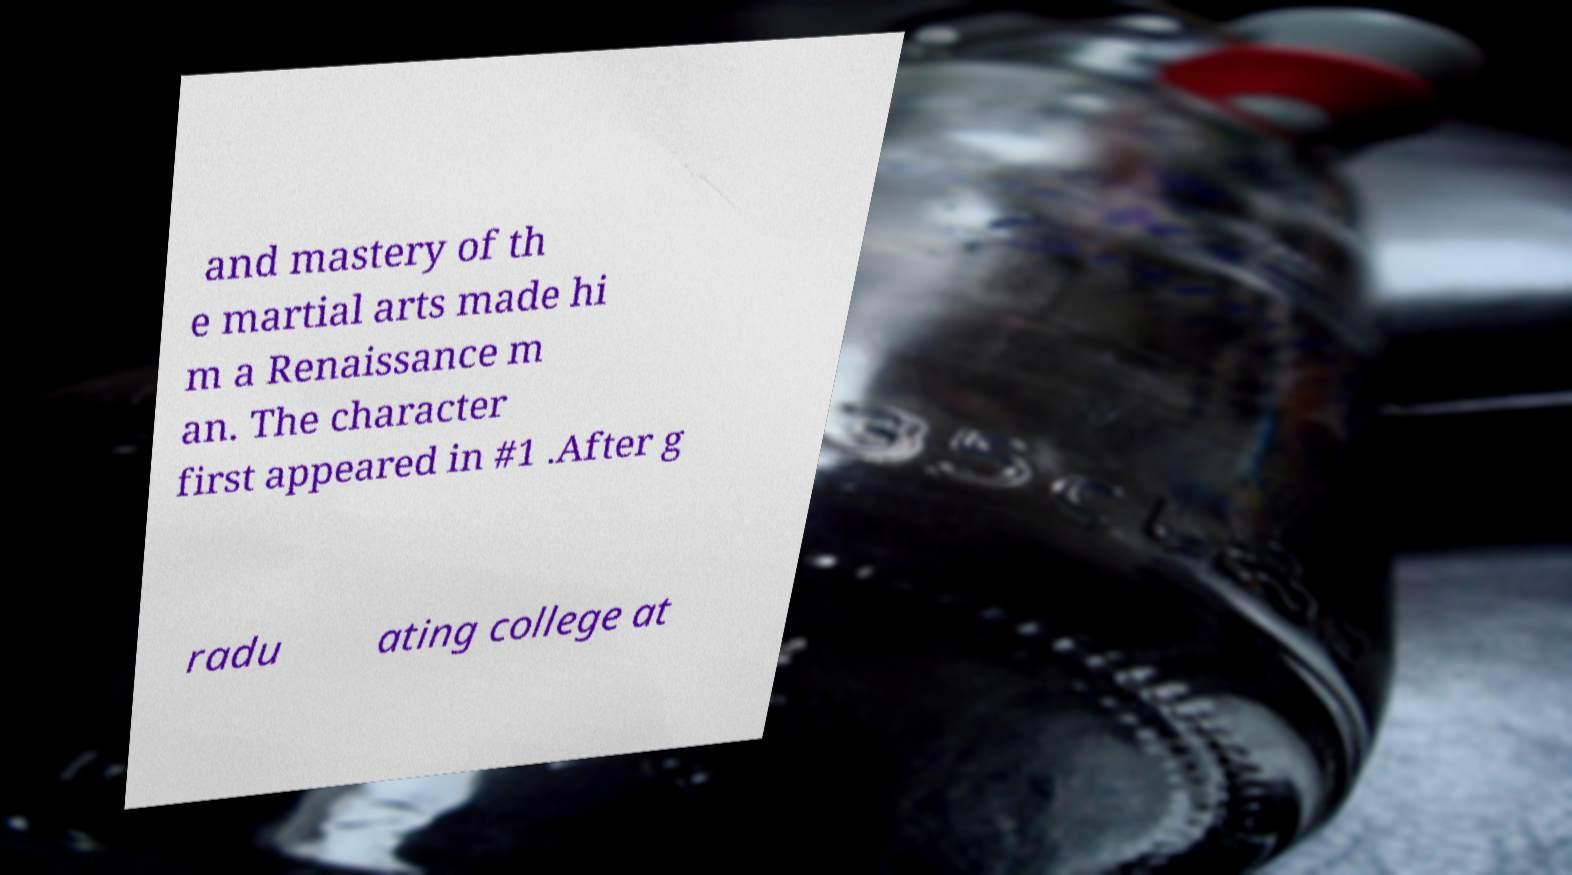Can you read and provide the text displayed in the image?This photo seems to have some interesting text. Can you extract and type it out for me? and mastery of th e martial arts made hi m a Renaissance m an. The character first appeared in #1 .After g radu ating college at 